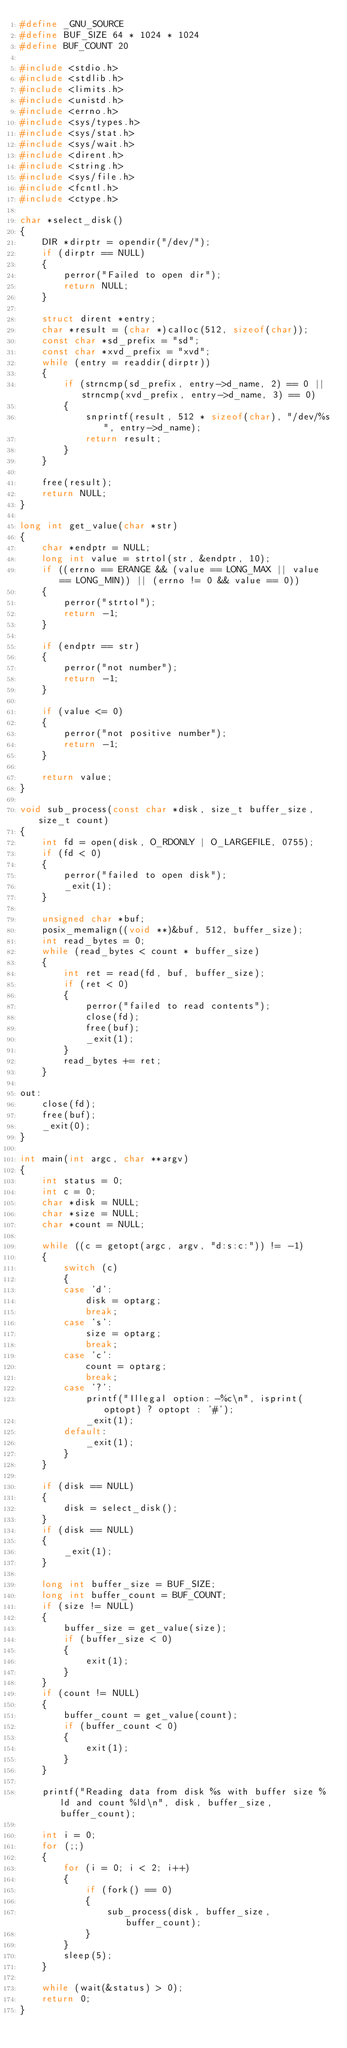<code> <loc_0><loc_0><loc_500><loc_500><_C_>#define _GNU_SOURCE
#define BUF_SIZE 64 * 1024 * 1024
#define BUF_COUNT 20

#include <stdio.h>
#include <stdlib.h>
#include <limits.h>
#include <unistd.h>
#include <errno.h>
#include <sys/types.h>
#include <sys/stat.h>
#include <sys/wait.h>
#include <dirent.h>
#include <string.h>
#include <sys/file.h>
#include <fcntl.h>
#include <ctype.h>

char *select_disk()
{
	DIR *dirptr = opendir("/dev/");
	if (dirptr == NULL)
	{
		perror("Failed to open dir");
		return NULL;
	}

	struct dirent *entry;
	char *result = (char *)calloc(512, sizeof(char));
	const char *sd_prefix = "sd";
	const char *xvd_prefix = "xvd";
	while (entry = readdir(dirptr))
	{
		if (strncmp(sd_prefix, entry->d_name, 2) == 0 || strncmp(xvd_prefix, entry->d_name, 3) == 0)
		{
			snprintf(result, 512 * sizeof(char), "/dev/%s", entry->d_name);
			return result;
		}
	}

	free(result);
	return NULL;
}

long int get_value(char *str)
{
	char *endptr = NULL;
	long int value = strtol(str, &endptr, 10);
	if ((errno == ERANGE && (value == LONG_MAX || value == LONG_MIN)) || (errno != 0 && value == 0))
	{
		perror("strtol");
		return -1;
	}

	if (endptr == str)
	{
		perror("not number");
		return -1;
	}

	if (value <= 0)
	{
		perror("not positive number");
		return -1;
	}

	return value;
}

void sub_process(const char *disk, size_t buffer_size, size_t count)
{
	int fd = open(disk, O_RDONLY | O_LARGEFILE, 0755);
	if (fd < 0)
	{
		perror("failed to open disk");
		_exit(1);
	}

	unsigned char *buf;
	posix_memalign((void **)&buf, 512, buffer_size);
	int read_bytes = 0;
	while (read_bytes < count * buffer_size)
	{
		int ret = read(fd, buf, buffer_size);
		if (ret < 0)
		{
			perror("failed to read contents");
			close(fd);
			free(buf);
			_exit(1);
		}
		read_bytes += ret;
	}

out:
	close(fd);
	free(buf);
	_exit(0);
}

int main(int argc, char **argv)
{
	int status = 0;
	int c = 0;
	char *disk = NULL;
	char *size = NULL;
	char *count = NULL;

	while ((c = getopt(argc, argv, "d:s:c:")) != -1)
	{
		switch (c)
		{
		case 'd':
			disk = optarg;
			break;
		case 's':
			size = optarg;
			break;
		case 'c':
			count = optarg;
			break;
		case '?':
			printf("Illegal option: -%c\n", isprint(optopt) ? optopt : '#');
			_exit(1);
		default:
			_exit(1);
		}
	}

	if (disk == NULL)
	{
		disk = select_disk();
	}
	if (disk == NULL)
	{
		_exit(1);
	}

	long int buffer_size = BUF_SIZE;
	long int buffer_count = BUF_COUNT;
	if (size != NULL)
	{
		buffer_size = get_value(size);
		if (buffer_size < 0)
		{
			exit(1);
		}
	}
	if (count != NULL)
	{
		buffer_count = get_value(count);
		if (buffer_count < 0)
		{
			exit(1);
		}
	}

	printf("Reading data from disk %s with buffer size %ld and count %ld\n", disk, buffer_size, buffer_count);

	int i = 0;
	for (;;)
	{
		for (i = 0; i < 2; i++)
		{
			if (fork() == 0)
			{
				sub_process(disk, buffer_size, buffer_count);
			}
		}
		sleep(5);
	}

	while (wait(&status) > 0);
	return 0;
}
</code> 